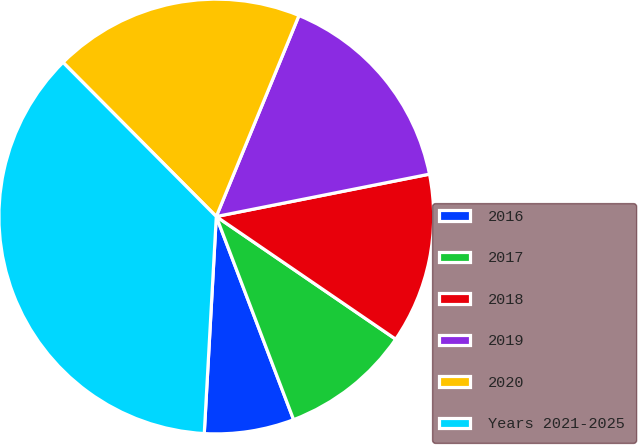Convert chart to OTSL. <chart><loc_0><loc_0><loc_500><loc_500><pie_chart><fcel>2016<fcel>2017<fcel>2018<fcel>2019<fcel>2020<fcel>Years 2021-2025<nl><fcel>6.67%<fcel>9.67%<fcel>12.67%<fcel>15.67%<fcel>18.67%<fcel>36.67%<nl></chart> 